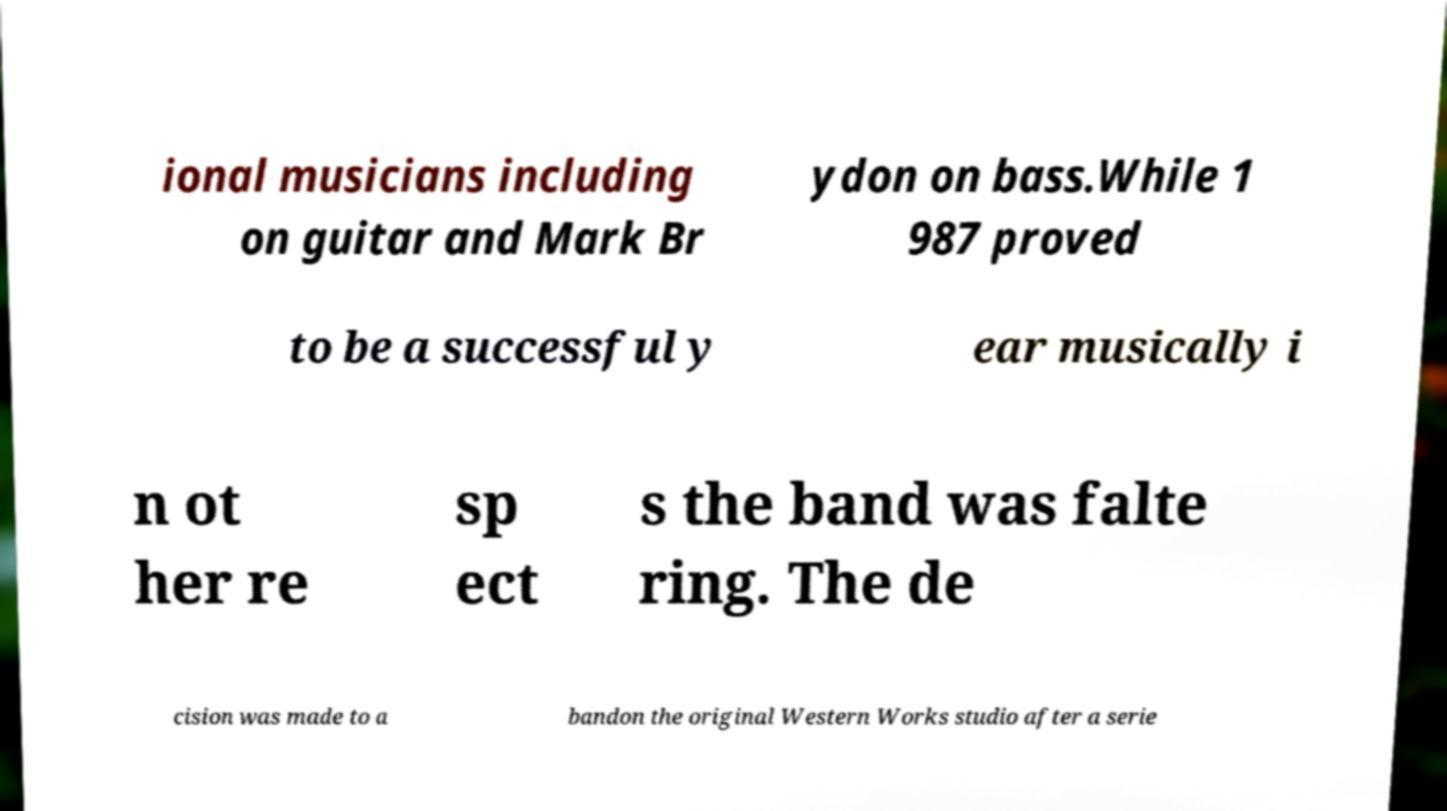I need the written content from this picture converted into text. Can you do that? ional musicians including on guitar and Mark Br ydon on bass.While 1 987 proved to be a successful y ear musically i n ot her re sp ect s the band was falte ring. The de cision was made to a bandon the original Western Works studio after a serie 